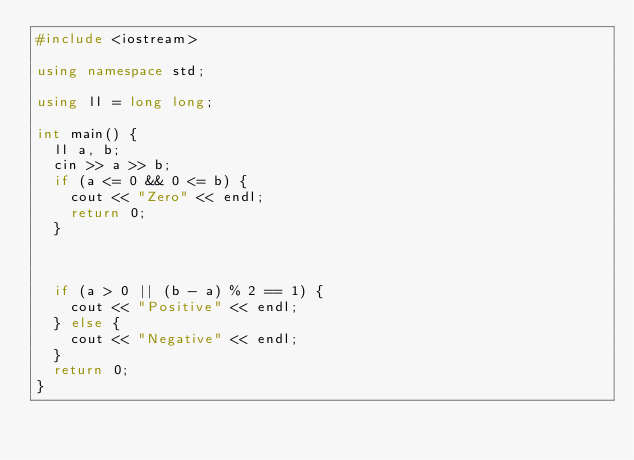<code> <loc_0><loc_0><loc_500><loc_500><_C++_>#include <iostream>

using namespace std;

using ll = long long;

int main() {
  ll a, b;
  cin >> a >> b;
  if (a <= 0 && 0 <= b) {
    cout << "Zero" << endl;
    return 0;
  }


  
  if (a > 0 || (b - a) % 2 == 1) {
    cout << "Positive" << endl;
  } else {
    cout << "Negative" << endl;
  }
  return 0;
}
</code> 